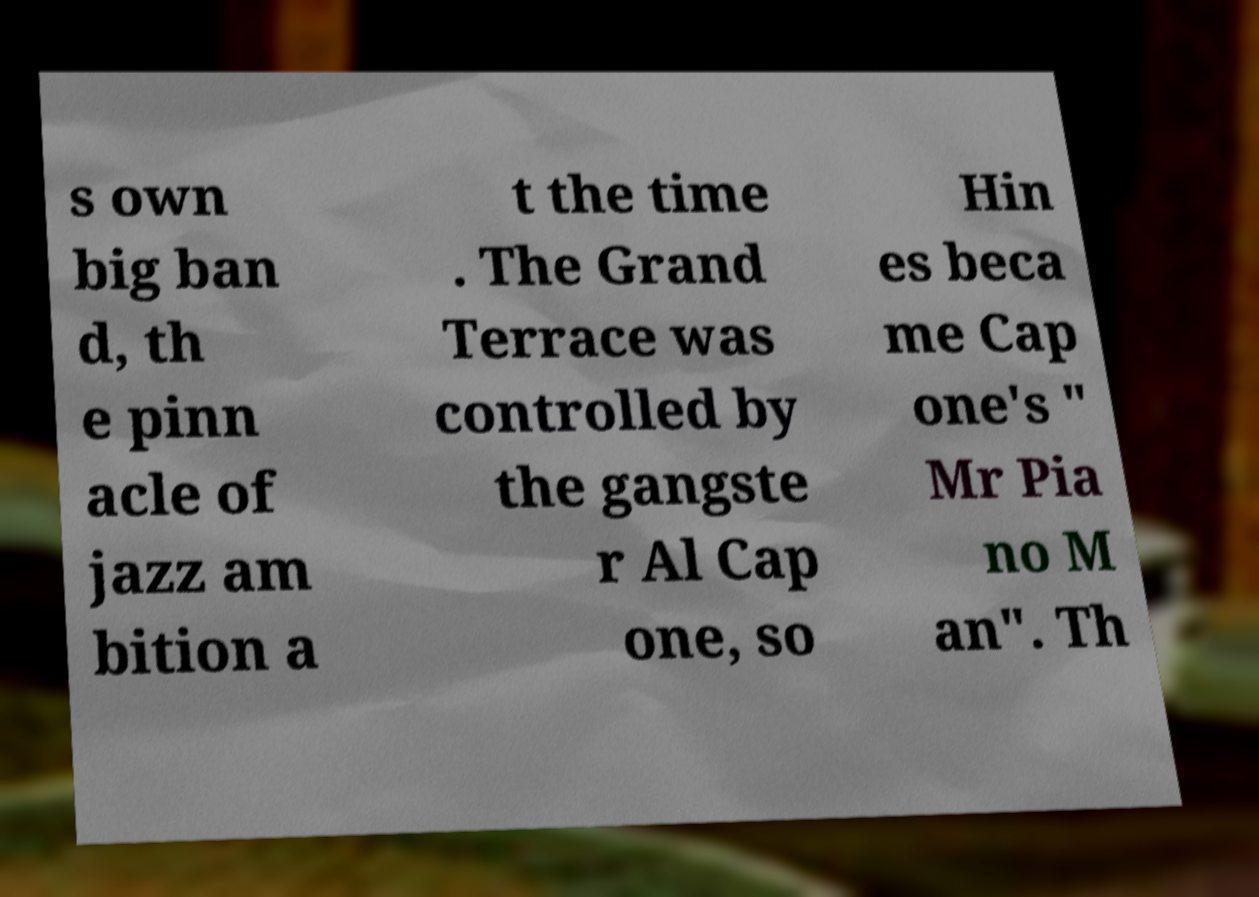Can you accurately transcribe the text from the provided image for me? s own big ban d, th e pinn acle of jazz am bition a t the time . The Grand Terrace was controlled by the gangste r Al Cap one, so Hin es beca me Cap one's " Mr Pia no M an". Th 